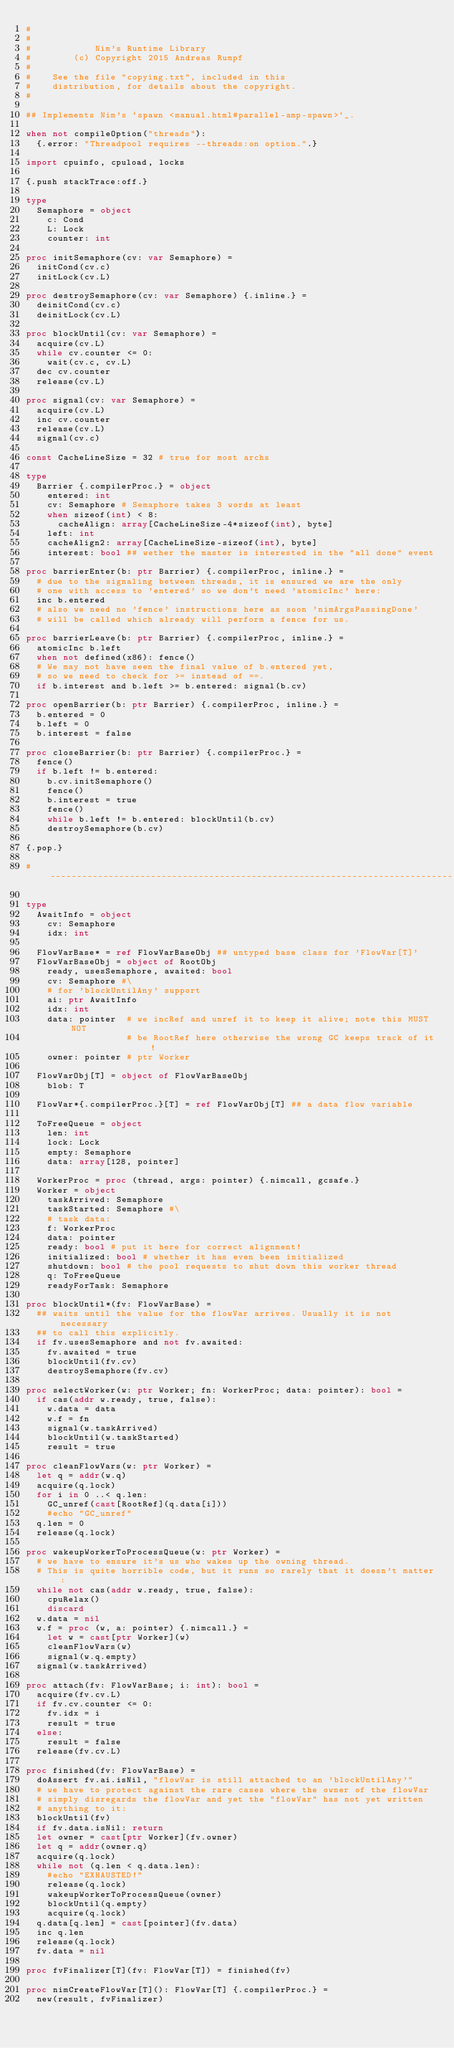Convert code to text. <code><loc_0><loc_0><loc_500><loc_500><_Nim_>#
#
#            Nim's Runtime Library
#        (c) Copyright 2015 Andreas Rumpf
#
#    See the file "copying.txt", included in this
#    distribution, for details about the copyright.
#

## Implements Nim's `spawn <manual.html#parallel-amp-spawn>`_.

when not compileOption("threads"):
  {.error: "Threadpool requires --threads:on option.".}

import cpuinfo, cpuload, locks

{.push stackTrace:off.}

type
  Semaphore = object
    c: Cond
    L: Lock
    counter: int

proc initSemaphore(cv: var Semaphore) =
  initCond(cv.c)
  initLock(cv.L)

proc destroySemaphore(cv: var Semaphore) {.inline.} =
  deinitCond(cv.c)
  deinitLock(cv.L)

proc blockUntil(cv: var Semaphore) =
  acquire(cv.L)
  while cv.counter <= 0:
    wait(cv.c, cv.L)
  dec cv.counter
  release(cv.L)

proc signal(cv: var Semaphore) =
  acquire(cv.L)
  inc cv.counter
  release(cv.L)
  signal(cv.c)

const CacheLineSize = 32 # true for most archs

type
  Barrier {.compilerProc.} = object
    entered: int
    cv: Semaphore # Semaphore takes 3 words at least
    when sizeof(int) < 8:
      cacheAlign: array[CacheLineSize-4*sizeof(int), byte]
    left: int
    cacheAlign2: array[CacheLineSize-sizeof(int), byte]
    interest: bool ## wether the master is interested in the "all done" event

proc barrierEnter(b: ptr Barrier) {.compilerProc, inline.} =
  # due to the signaling between threads, it is ensured we are the only
  # one with access to 'entered' so we don't need 'atomicInc' here:
  inc b.entered
  # also we need no 'fence' instructions here as soon 'nimArgsPassingDone'
  # will be called which already will perform a fence for us.

proc barrierLeave(b: ptr Barrier) {.compilerProc, inline.} =
  atomicInc b.left
  when not defined(x86): fence()
  # We may not have seen the final value of b.entered yet,
  # so we need to check for >= instead of ==.
  if b.interest and b.left >= b.entered: signal(b.cv)

proc openBarrier(b: ptr Barrier) {.compilerProc, inline.} =
  b.entered = 0
  b.left = 0
  b.interest = false

proc closeBarrier(b: ptr Barrier) {.compilerProc.} =
  fence()
  if b.left != b.entered:
    b.cv.initSemaphore()
    fence()
    b.interest = true
    fence()
    while b.left != b.entered: blockUntil(b.cv)
    destroySemaphore(b.cv)

{.pop.}

# ----------------------------------------------------------------------------

type
  AwaitInfo = object
    cv: Semaphore
    idx: int

  FlowVarBase* = ref FlowVarBaseObj ## untyped base class for 'FlowVar[T]'
  FlowVarBaseObj = object of RootObj
    ready, usesSemaphore, awaited: bool
    cv: Semaphore #\
    # for 'blockUntilAny' support
    ai: ptr AwaitInfo
    idx: int
    data: pointer  # we incRef and unref it to keep it alive; note this MUST NOT
                   # be RootRef here otherwise the wrong GC keeps track of it!
    owner: pointer # ptr Worker

  FlowVarObj[T] = object of FlowVarBaseObj
    blob: T

  FlowVar*{.compilerProc.}[T] = ref FlowVarObj[T] ## a data flow variable

  ToFreeQueue = object
    len: int
    lock: Lock
    empty: Semaphore
    data: array[128, pointer]

  WorkerProc = proc (thread, args: pointer) {.nimcall, gcsafe.}
  Worker = object
    taskArrived: Semaphore
    taskStarted: Semaphore #\
    # task data:
    f: WorkerProc
    data: pointer
    ready: bool # put it here for correct alignment!
    initialized: bool # whether it has even been initialized
    shutdown: bool # the pool requests to shut down this worker thread
    q: ToFreeQueue
    readyForTask: Semaphore

proc blockUntil*(fv: FlowVarBase) =
  ## waits until the value for the flowVar arrives. Usually it is not necessary
  ## to call this explicitly.
  if fv.usesSemaphore and not fv.awaited:
    fv.awaited = true
    blockUntil(fv.cv)
    destroySemaphore(fv.cv)

proc selectWorker(w: ptr Worker; fn: WorkerProc; data: pointer): bool =
  if cas(addr w.ready, true, false):
    w.data = data
    w.f = fn
    signal(w.taskArrived)
    blockUntil(w.taskStarted)
    result = true

proc cleanFlowVars(w: ptr Worker) =
  let q = addr(w.q)
  acquire(q.lock)
  for i in 0 ..< q.len:
    GC_unref(cast[RootRef](q.data[i]))
    #echo "GC_unref"
  q.len = 0
  release(q.lock)

proc wakeupWorkerToProcessQueue(w: ptr Worker) =
  # we have to ensure it's us who wakes up the owning thread.
  # This is quite horrible code, but it runs so rarely that it doesn't matter:
  while not cas(addr w.ready, true, false):
    cpuRelax()
    discard
  w.data = nil
  w.f = proc (w, a: pointer) {.nimcall.} =
    let w = cast[ptr Worker](w)
    cleanFlowVars(w)
    signal(w.q.empty)
  signal(w.taskArrived)

proc attach(fv: FlowVarBase; i: int): bool =
  acquire(fv.cv.L)
  if fv.cv.counter <= 0:
    fv.idx = i
    result = true
  else:
    result = false
  release(fv.cv.L)

proc finished(fv: FlowVarBase) =
  doAssert fv.ai.isNil, "flowVar is still attached to an 'blockUntilAny'"
  # we have to protect against the rare cases where the owner of the flowVar
  # simply disregards the flowVar and yet the "flowVar" has not yet written
  # anything to it:
  blockUntil(fv)
  if fv.data.isNil: return
  let owner = cast[ptr Worker](fv.owner)
  let q = addr(owner.q)
  acquire(q.lock)
  while not (q.len < q.data.len):
    #echo "EXHAUSTED!"
    release(q.lock)
    wakeupWorkerToProcessQueue(owner)
    blockUntil(q.empty)
    acquire(q.lock)
  q.data[q.len] = cast[pointer](fv.data)
  inc q.len
  release(q.lock)
  fv.data = nil

proc fvFinalizer[T](fv: FlowVar[T]) = finished(fv)

proc nimCreateFlowVar[T](): FlowVar[T] {.compilerProc.} =
  new(result, fvFinalizer)
</code> 